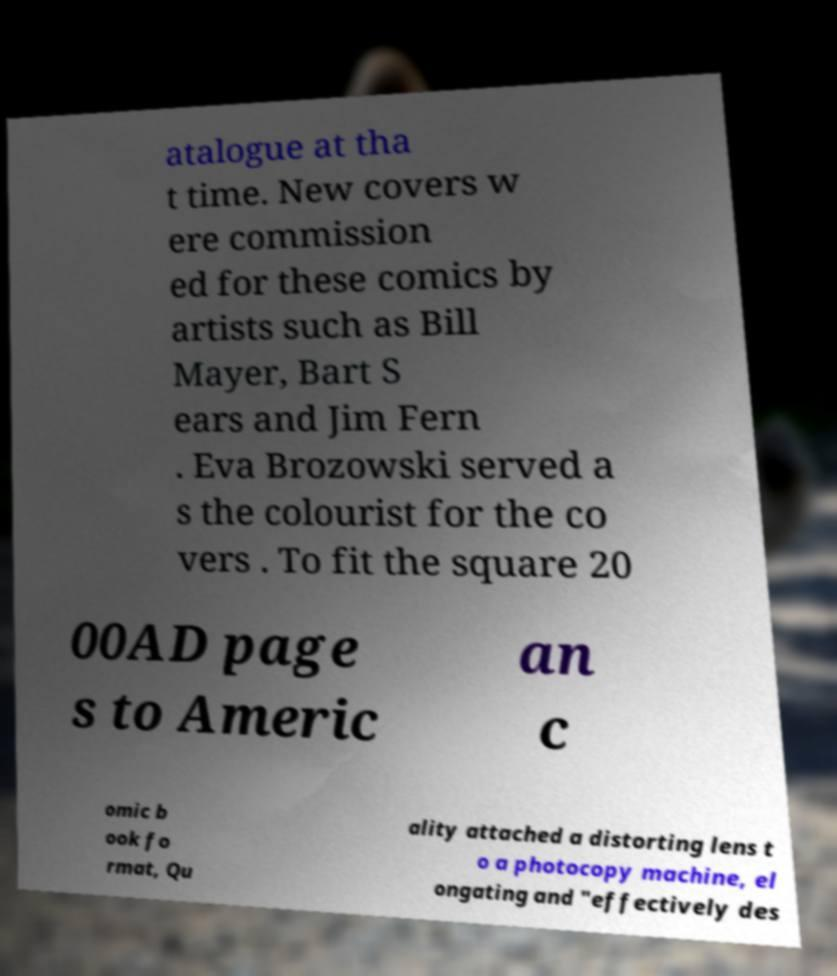Could you assist in decoding the text presented in this image and type it out clearly? atalogue at tha t time. New covers w ere commission ed for these comics by artists such as Bill Mayer, Bart S ears and Jim Fern . Eva Brozowski served a s the colourist for the co vers . To fit the square 20 00AD page s to Americ an c omic b ook fo rmat, Qu ality attached a distorting lens t o a photocopy machine, el ongating and "effectively des 